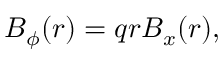Convert formula to latex. <formula><loc_0><loc_0><loc_500><loc_500>\begin{array} { r } { B _ { \phi } ( r ) = q r B _ { x } ( r ) , } \end{array}</formula> 